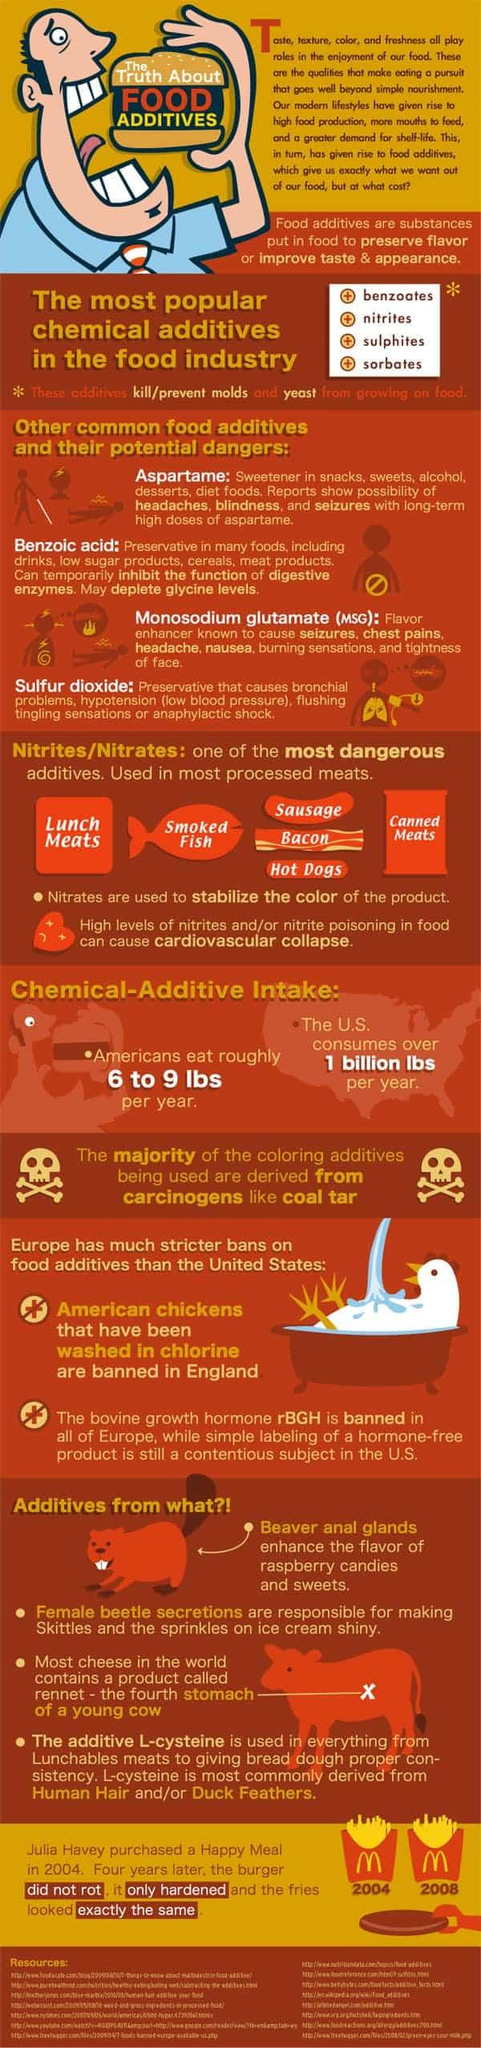Identify some key points in this picture. Aspartame is commonly used in cereals or alcoholic beverages as a sweetener. Aspartame is the additive that can cause blindness, according to the message or information. The additive used in smoked fish is called nitrites/nitrates. Benzoic acid or MSG causes chest pain. Benzoic acid is commonly used in snacks and drinks. Specifically, it is more commonly used in drinks. 